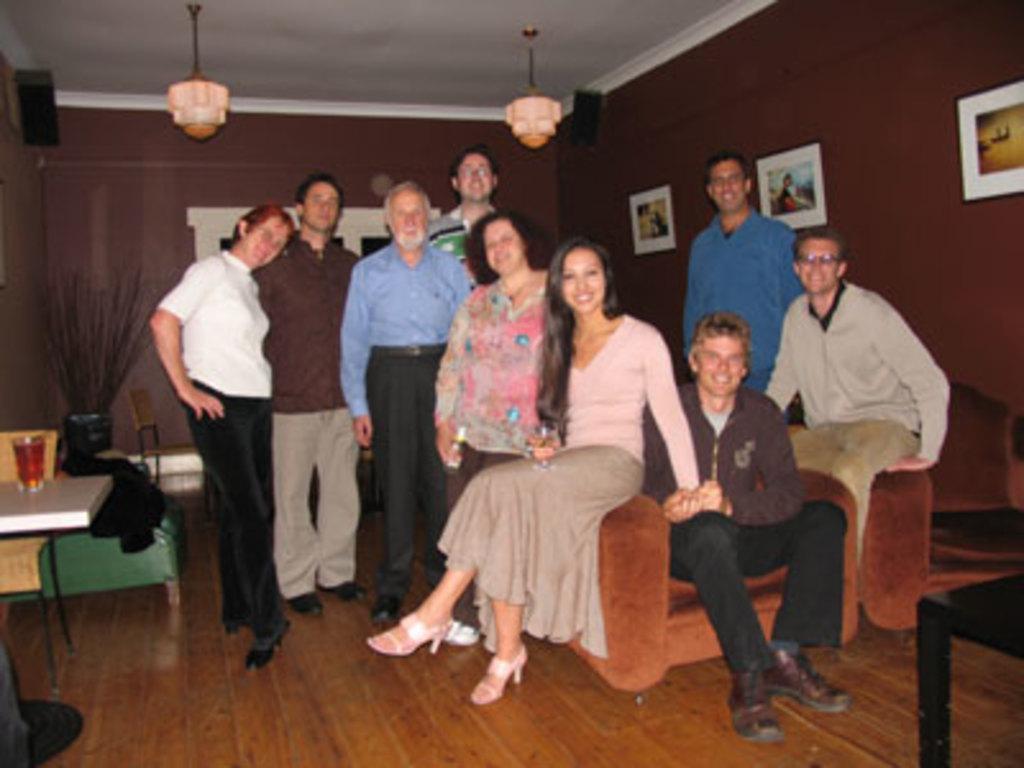How would you summarize this image in a sentence or two? In the picture we can see some people are standing in the house on the wooden floor and some people are sitting on the sofa chair and in the background we can see a wall with some photo frames to it and to the ceiling we can see some lights hanged to it and to the floor we can see some table and something placed on it. 